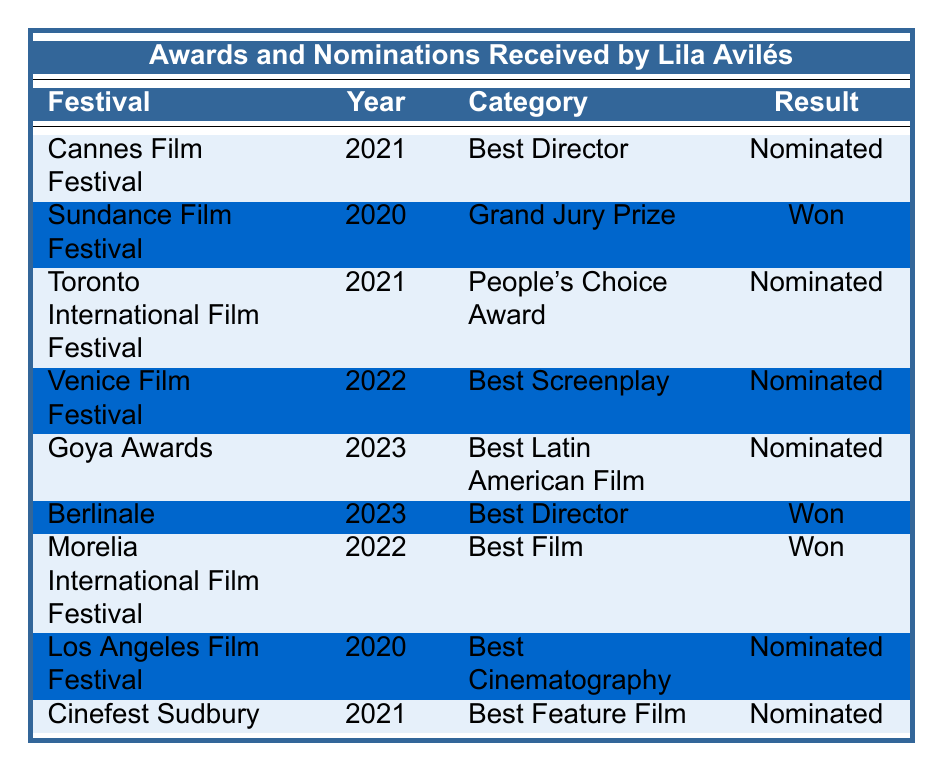What award did Lila Avilés win at the Sundance Film Festival? The table shows that Lila Avilés won the Grand Jury Prize at the Sundance Film Festival in 2020.
Answer: Grand Jury Prize How many times has Lila Avilés been nominated for Best Director? She has been nominated for Best Director at two festivals: Cannes Film Festival in 2021 and Berlinale in 2023.
Answer: 2 times Which festival awarded Lila Avilés for Best Film? According to the table, Lila Avilés won the Best Film award at the Morelia International Film Festival in 2022.
Answer: Morelia International Film Festival Did Lila Avilés receive more wins or nominations in 2021? In 2021, she had 1 win (Sundance) and 3 nominations (Cannes, Toronto, Cinefest Sudbury), so she had more nominations.
Answer: Nominations What is the total number of awards and nominations Lila Avilés received across all festivals listed? Counting the entries, there are a total of 9 entries in the table (4 wins and 5 nominations), which means she received 9 awards/nominations in total.
Answer: 9 Which year did Lila Avilés not receive any nominations? Looking at the table, 2022 shows two wins but no nominations, while 2023 has one nomination. Therefore, 2020 has nominations only.
Answer: None Was Lila Avilés nominated for the People's Choice Award? The table states that she was indeed nominated for the People's Choice Award at the Toronto International Film Festival in 2021.
Answer: Yes What percentage of Lila Avilés' total entries are wins? There are 4 wins out of a total of 9 entries. The percentage of wins is (4/9) * 100, which results in approximately 44.44%.
Answer: 44.44% How many festivals did Lila Avilés participate in during 2023? She participated in two festivals in 2023: Goya Awards and Berlinale, as reflected in the table.
Answer: 2 festivals What is the category Lila Avilés was nominated for at the Venice Film Festival? The table indicates that she was nominated for Best Screenplay at the Venice Film Festival in 2022.
Answer: Best Screenplay 